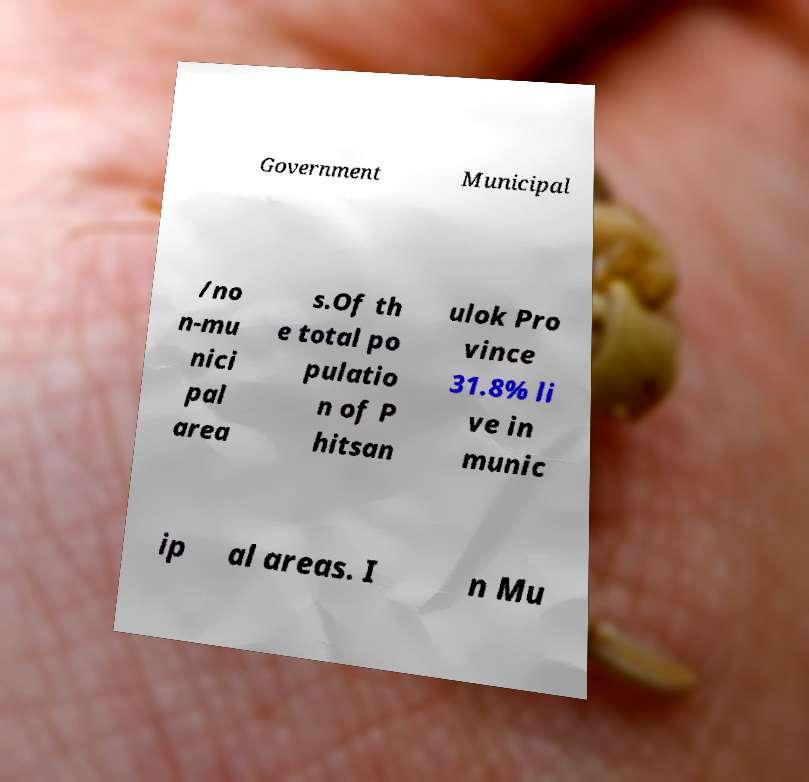Can you read and provide the text displayed in the image?This photo seems to have some interesting text. Can you extract and type it out for me? Government Municipal /no n-mu nici pal area s.Of th e total po pulatio n of P hitsan ulok Pro vince 31.8% li ve in munic ip al areas. I n Mu 